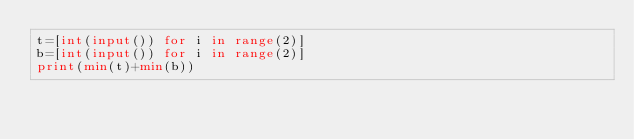Convert code to text. <code><loc_0><loc_0><loc_500><loc_500><_Python_>t=[int(input()) for i in range(2)]
b=[int(input()) for i in range(2)]
print(min(t)+min(b))
</code> 